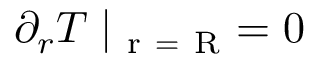<formula> <loc_0><loc_0><loc_500><loc_500>\partial _ { r } T | _ { r = R } = 0</formula> 